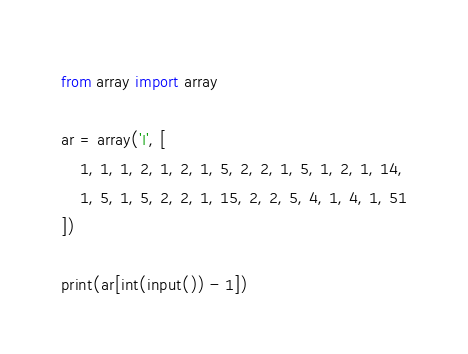<code> <loc_0><loc_0><loc_500><loc_500><_Python_>from array import array

ar = array('I', [
    1, 1, 1, 2, 1, 2, 1, 5, 2, 2, 1, 5, 1, 2, 1, 14,
    1, 5, 1, 5, 2, 2, 1, 15, 2, 2, 5, 4, 1, 4, 1, 51
])

print(ar[int(input()) - 1])
</code> 